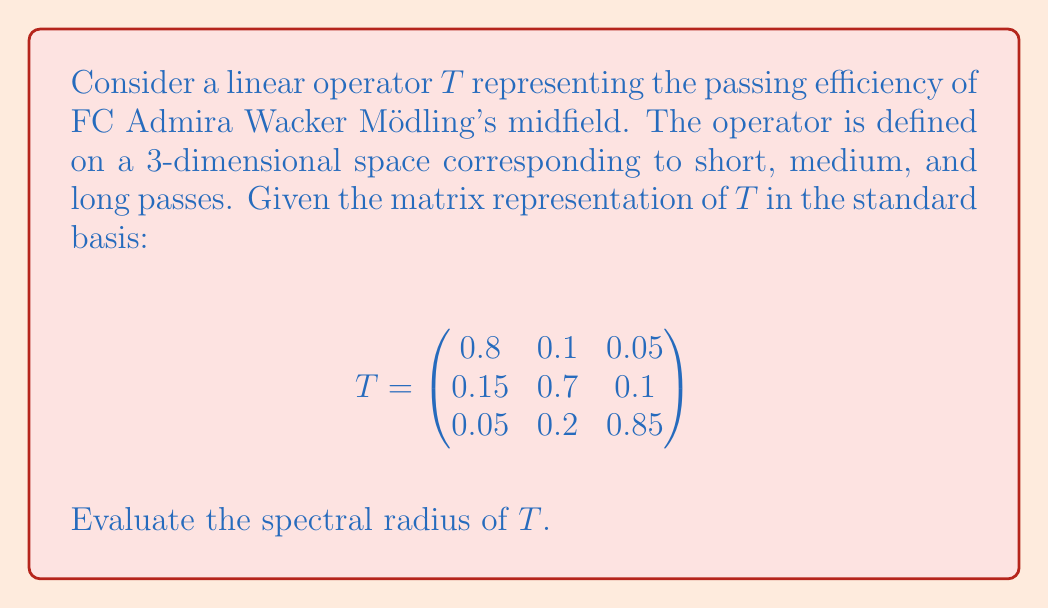Show me your answer to this math problem. To find the spectral radius of the linear operator $T$, we need to follow these steps:

1) First, recall that the spectral radius $\rho(T)$ is defined as:
   $$\rho(T) = \max\{|\lambda| : \lambda \text{ is an eigenvalue of } T\}$$

2) To find the eigenvalues, we need to solve the characteristic equation:
   $$\det(T - \lambda I) = 0$$

3) Expanding the determinant:
   $$\begin{vmatrix}
   0.8-\lambda & 0.1 & 0.05 \\
   0.15 & 0.7-\lambda & 0.1 \\
   0.05 & 0.2 & 0.85-\lambda
   \end{vmatrix} = 0$$

4) This gives us the characteristic polynomial:
   $$-\lambda^3 + 2.35\lambda^2 - 1.8275\lambda + 0.4615 = 0$$

5) Solving this equation (using numerical methods or a computer algebra system) yields the eigenvalues:
   $$\lambda_1 \approx 0.9962, \lambda_2 \approx 0.7030, \lambda_3 \approx 0.6508$$

6) The spectral radius is the maximum absolute value of these eigenvalues:
   $$\rho(T) = \max\{|0.9962|, |0.7030|, |0.6508|\} = 0.9962$$

Therefore, the spectral radius of $T$ is approximately 0.9962.
Answer: The spectral radius of $T$ is approximately 0.9962. 